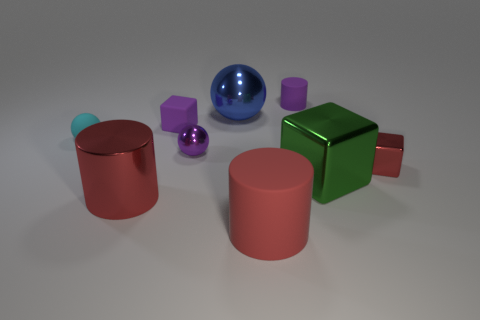Are there any blocks of the same color as the small cylinder?
Make the answer very short. Yes. There is a metal thing that is in front of the green cube; does it have the same shape as the big green metal object?
Provide a succinct answer. No. How many other red metal cylinders are the same size as the metal cylinder?
Your answer should be compact. 0. How many rubber balls are in front of the small shiny thing to the right of the tiny metallic ball?
Your answer should be compact. 0. Do the cube behind the tiny matte ball and the tiny cyan ball have the same material?
Provide a short and direct response. Yes. Do the red object right of the tiny rubber cylinder and the big red thing to the right of the tiny purple ball have the same material?
Your answer should be compact. No. Is the number of small purple metal objects behind the big rubber object greater than the number of purple metallic spheres?
Give a very brief answer. No. What color is the cylinder behind the large thing that is behind the small cyan matte sphere?
Keep it short and to the point. Purple. What shape is the cyan object that is the same size as the red shiny cube?
Your answer should be compact. Sphere. What is the shape of the small metallic thing that is the same color as the big shiny cylinder?
Keep it short and to the point. Cube. 